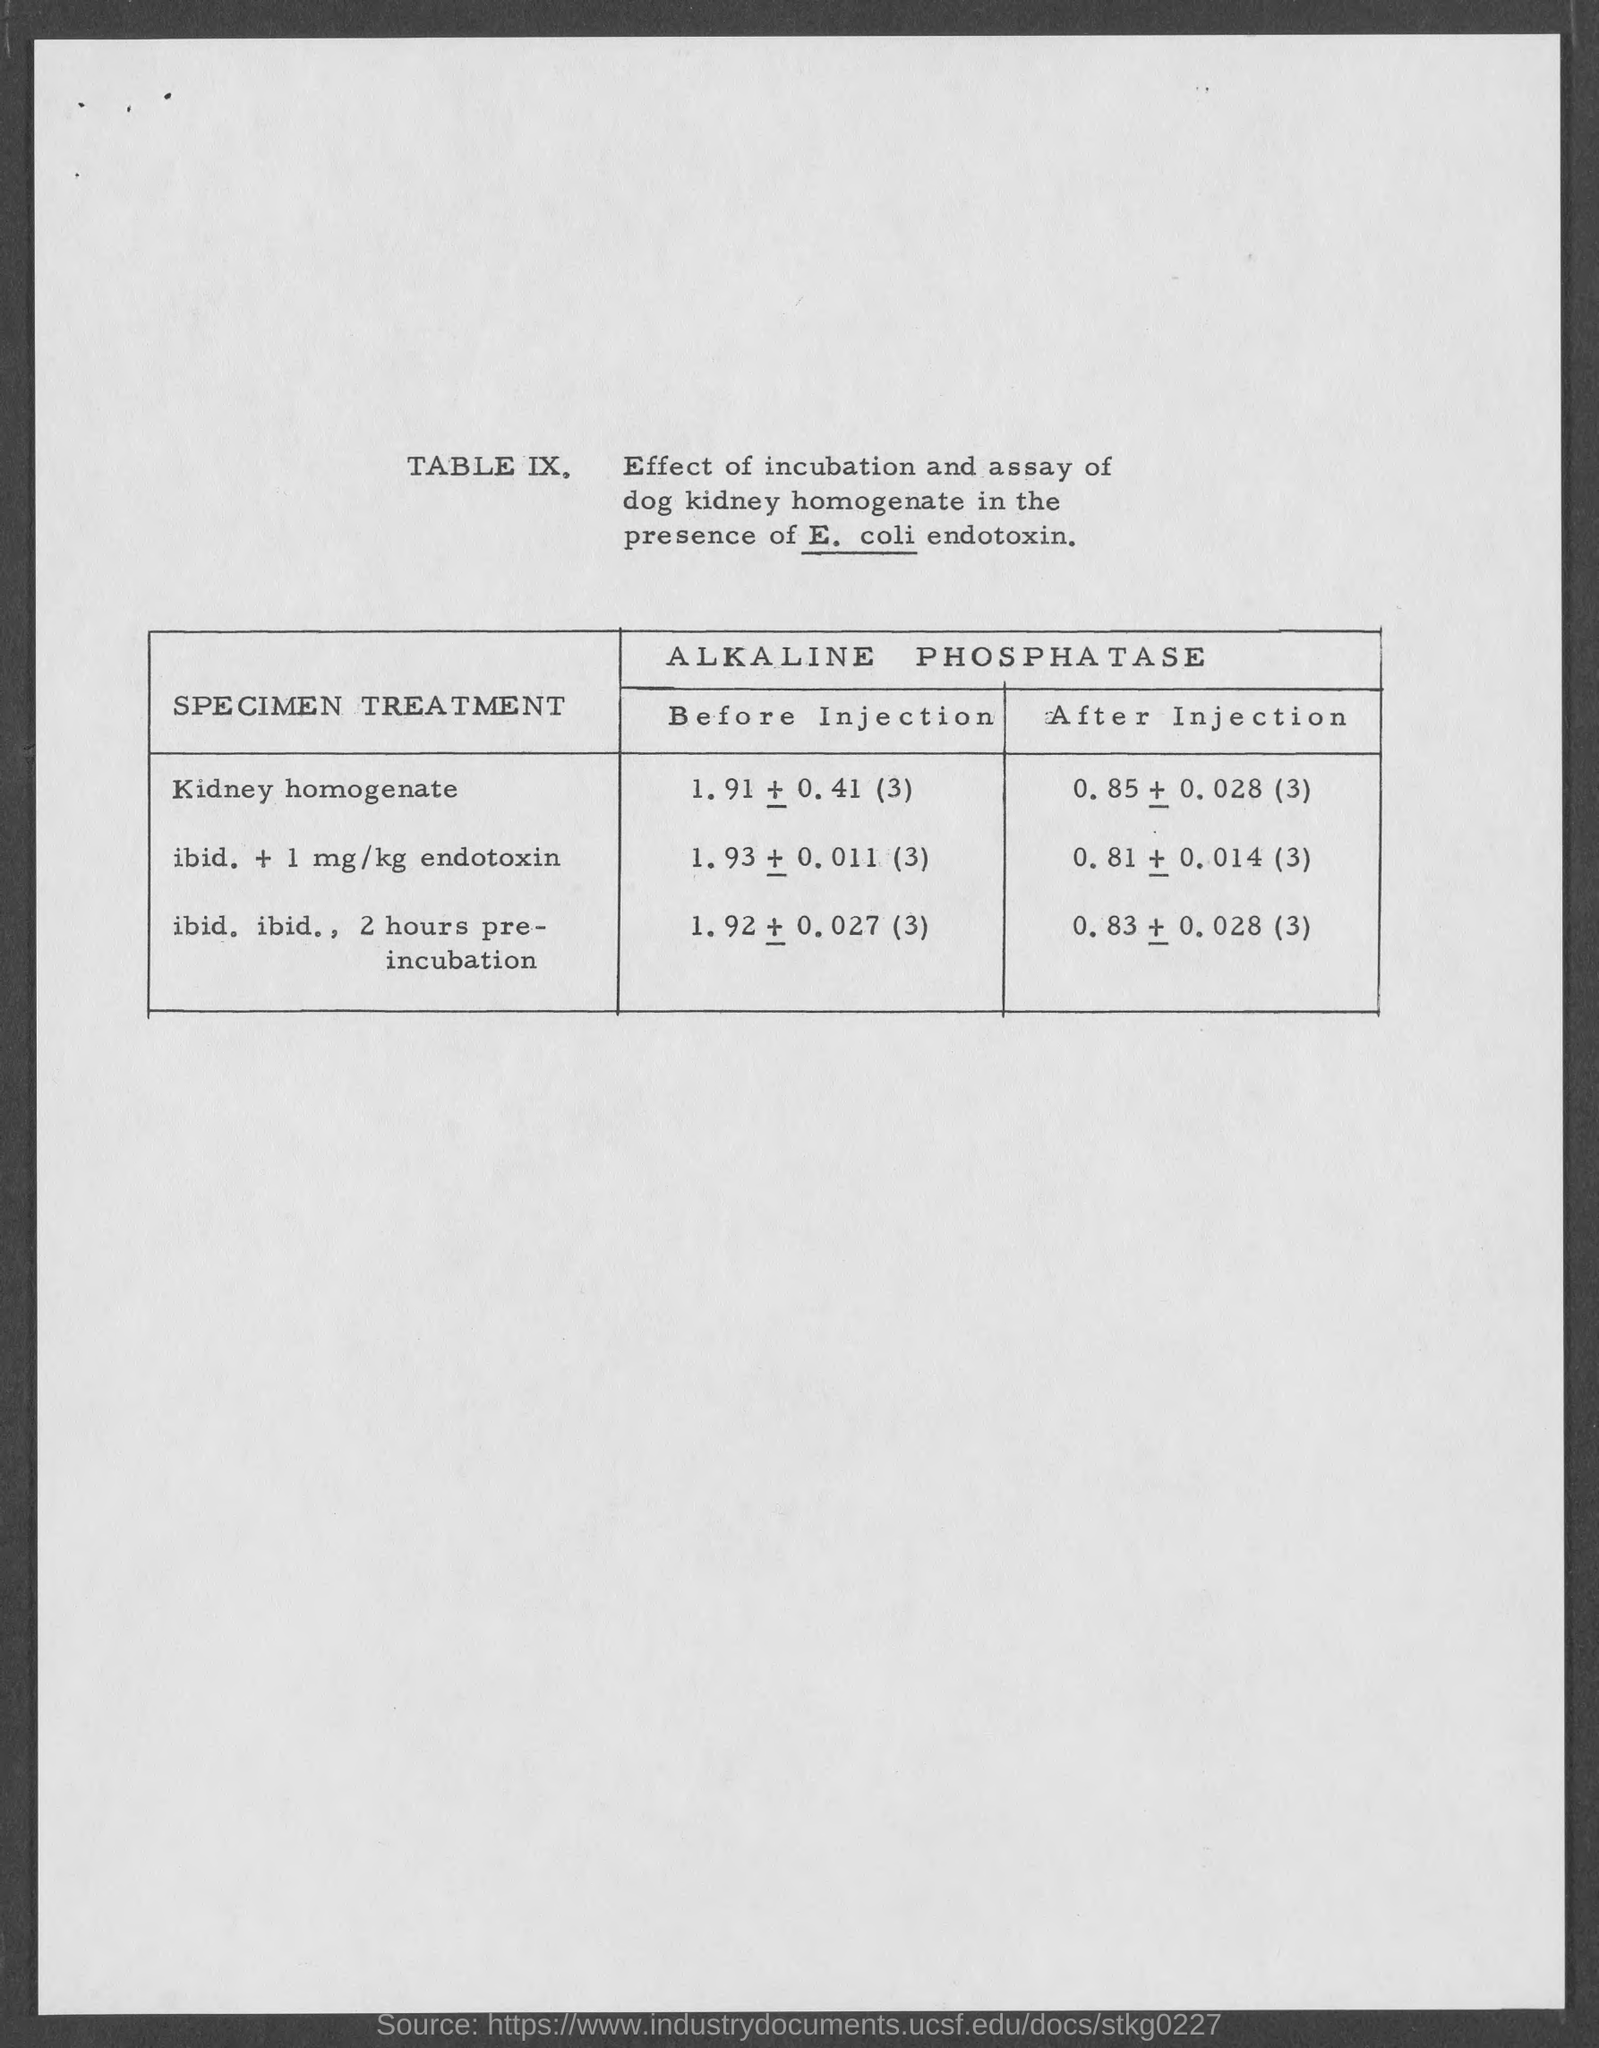Identify some key points in this picture. The heading of the table refers to the effect of incubation and assay of dog kidney homogenate in the presence of E. coli endotoxin. The first specimen treatment is kidney homogenate. The heading of the first column in the table is "Species/Treatment. 